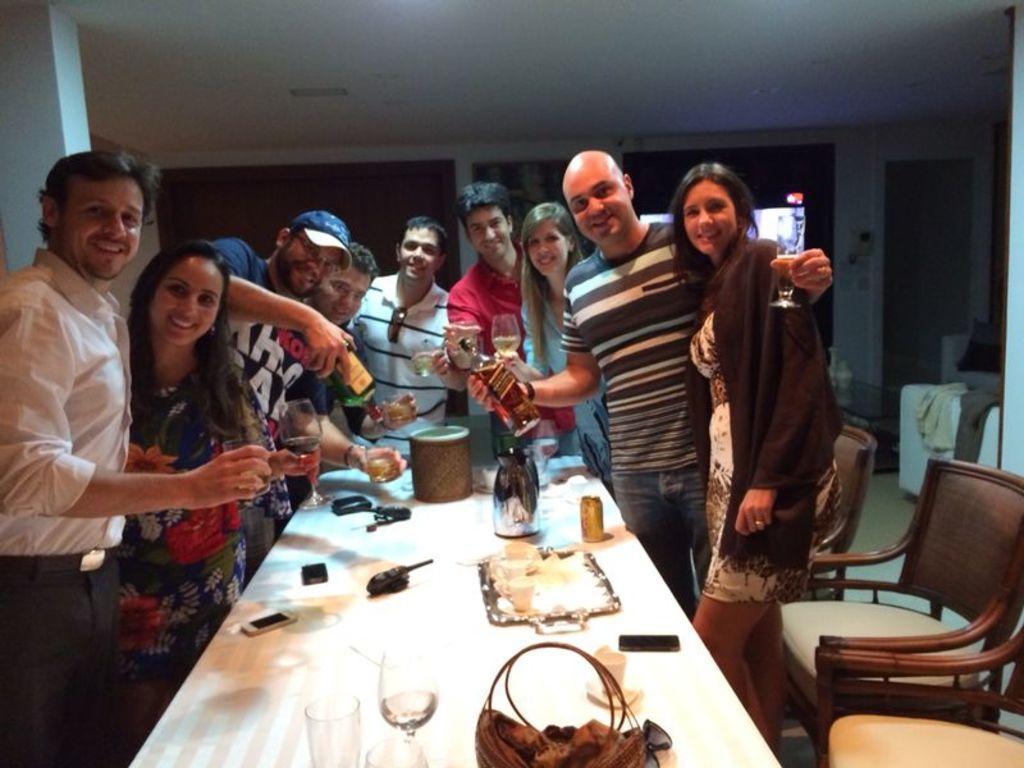Can you describe this image briefly? As we can see in the image there are few people standing over here. In the front there is a table. On table there is a mobile phone, plate and mug. On the right side there are chairs. 